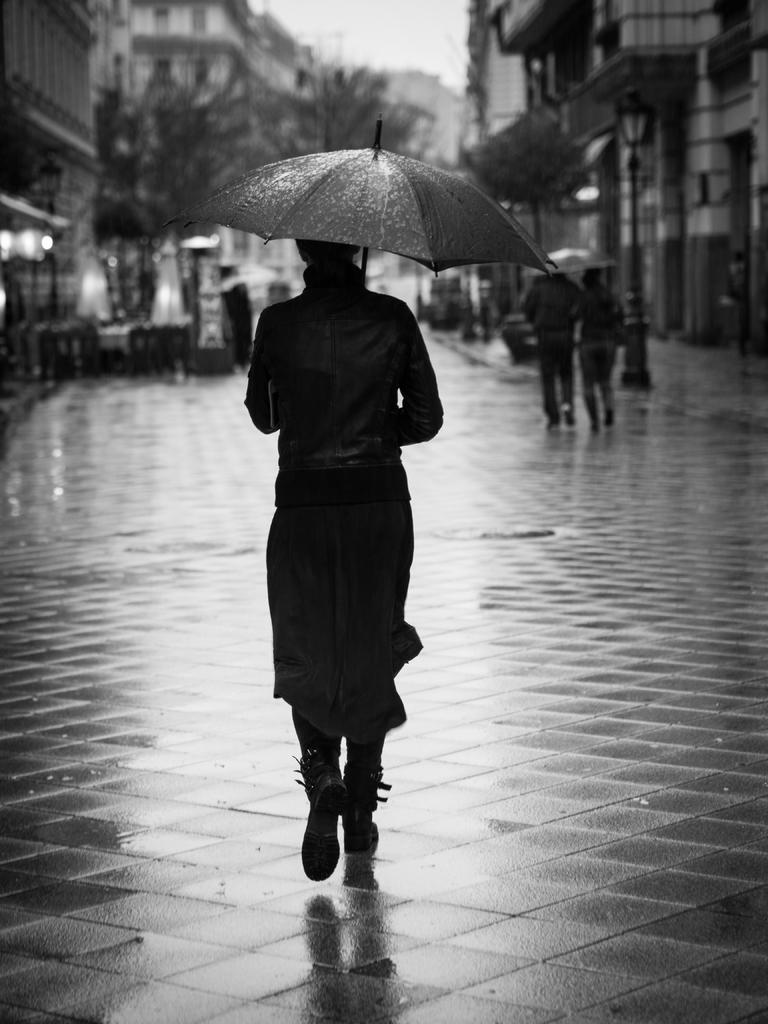What is the main feature of the image? There is a road in the image. What are the people on the road doing? There are people walking on the road. How are some of the people protecting themselves from the weather? Some of the people are holding umbrellas. What can be seen beside the road? There are buildings and trees beside the road. How many servants are visible in the image? There is no mention of servants in the image; it features a road with people walking on it. What type of place is depicted in the image? The image does not depict a specific type of place; it simply shows a road with people walking on it and the surrounding buildings and trees. 